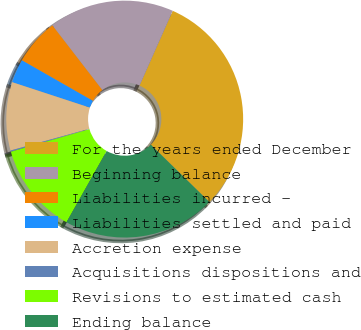Convert chart to OTSL. <chart><loc_0><loc_0><loc_500><loc_500><pie_chart><fcel>For the years ended December<fcel>Beginning balance<fcel>Liabilities incurred -<fcel>Liabilities settled and paid<fcel>Accretion expense<fcel>Acquisitions dispositions and<fcel>Revisions to estimated cash<fcel>Ending balance<nl><fcel>30.69%<fcel>17.11%<fcel>6.27%<fcel>3.22%<fcel>9.32%<fcel>0.17%<fcel>12.38%<fcel>20.84%<nl></chart> 